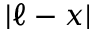Convert formula to latex. <formula><loc_0><loc_0><loc_500><loc_500>| \ell - x |</formula> 